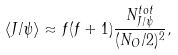Convert formula to latex. <formula><loc_0><loc_0><loc_500><loc_500>\langle J / \psi \rangle \approx f ( f + 1 ) \frac { N _ { J / \psi } ^ { t o t } } { ( N _ { O } / 2 ) ^ { 2 } } ,</formula> 